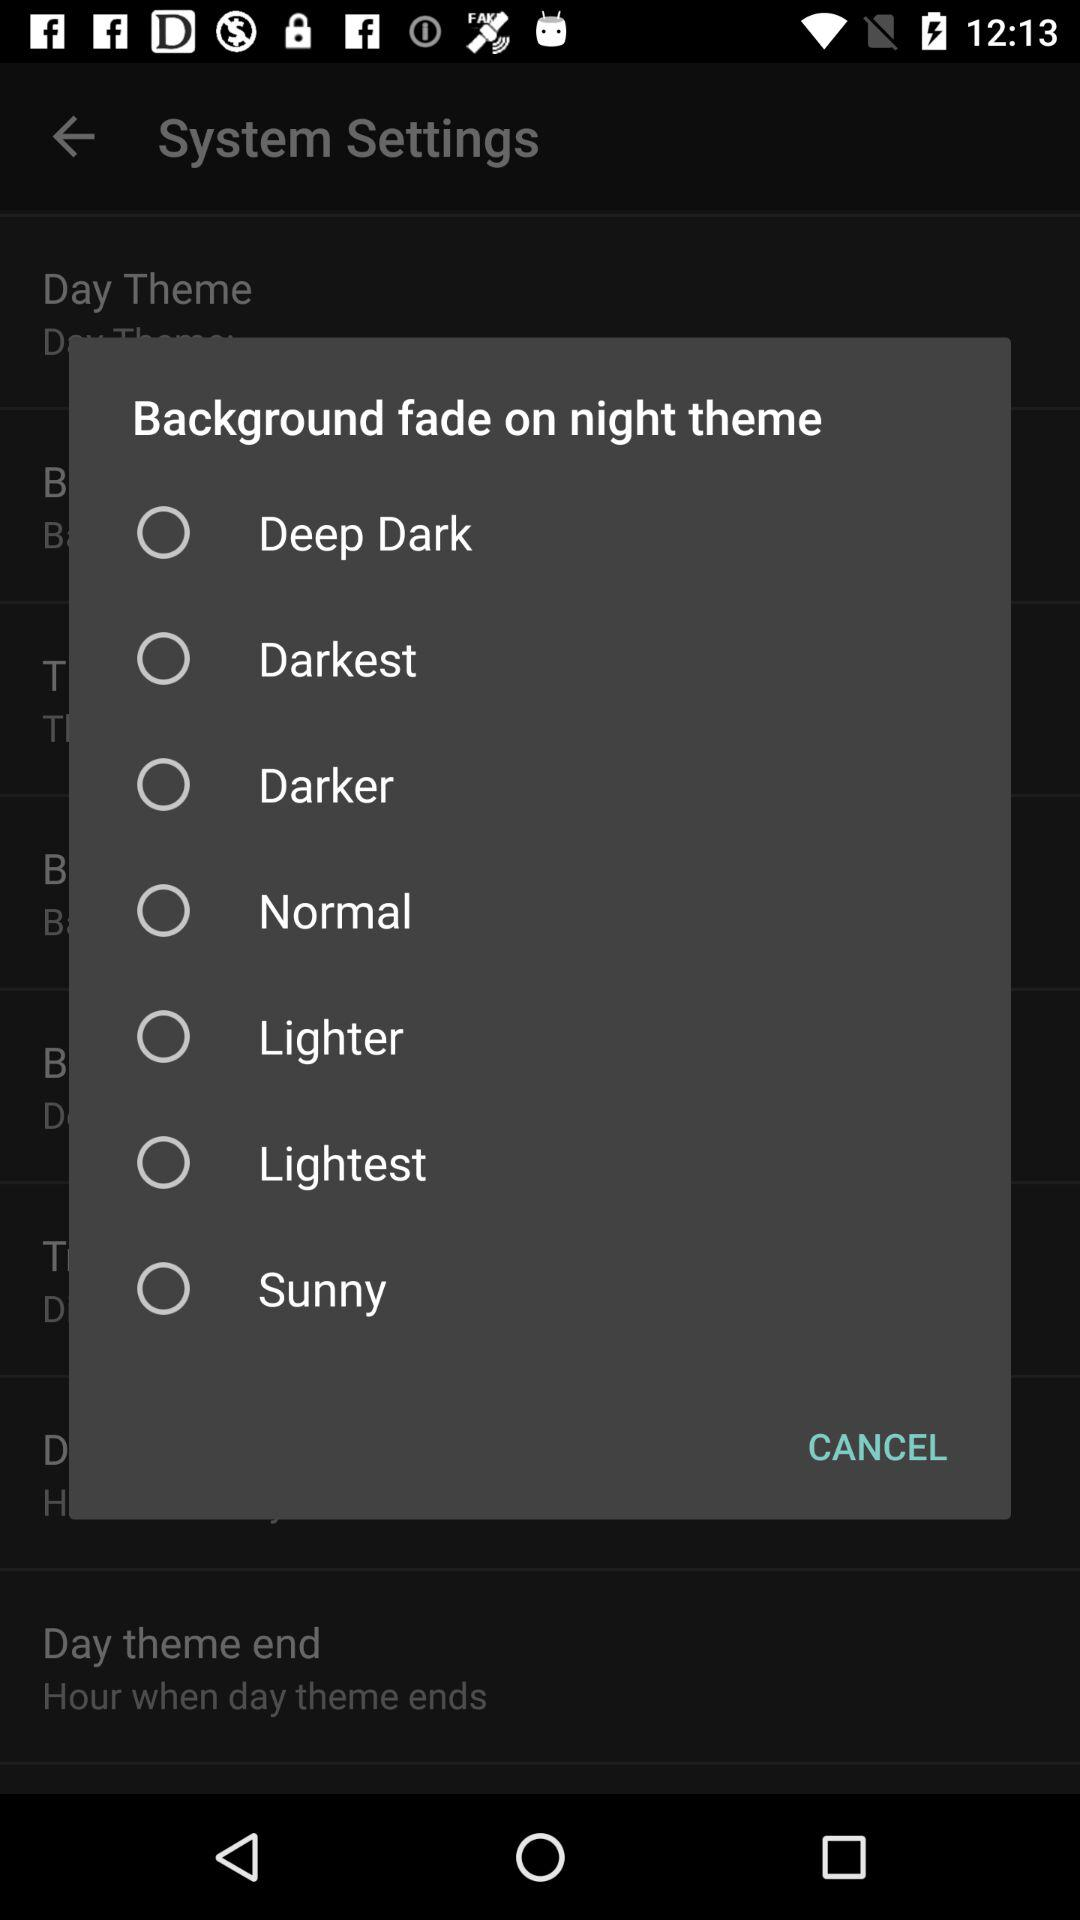Is "Sunny" selected or not? "Sunny" is not selected. 